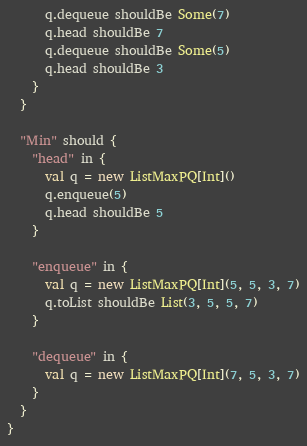<code> <loc_0><loc_0><loc_500><loc_500><_Scala_>      q.dequeue shouldBe Some(7)
      q.head shouldBe 7
      q.dequeue shouldBe Some(5)
      q.head shouldBe 3
    }
  }

  "Min" should {
    "head" in {
      val q = new ListMaxPQ[Int]()
      q.enqueue(5)
      q.head shouldBe 5
    }

    "enqueue" in {
      val q = new ListMaxPQ[Int](5, 5, 3, 7)
      q.toList shouldBe List(3, 5, 5, 7)
    }

    "dequeue" in {
      val q = new ListMaxPQ[Int](7, 5, 3, 7)
    }
  }
}
</code> 